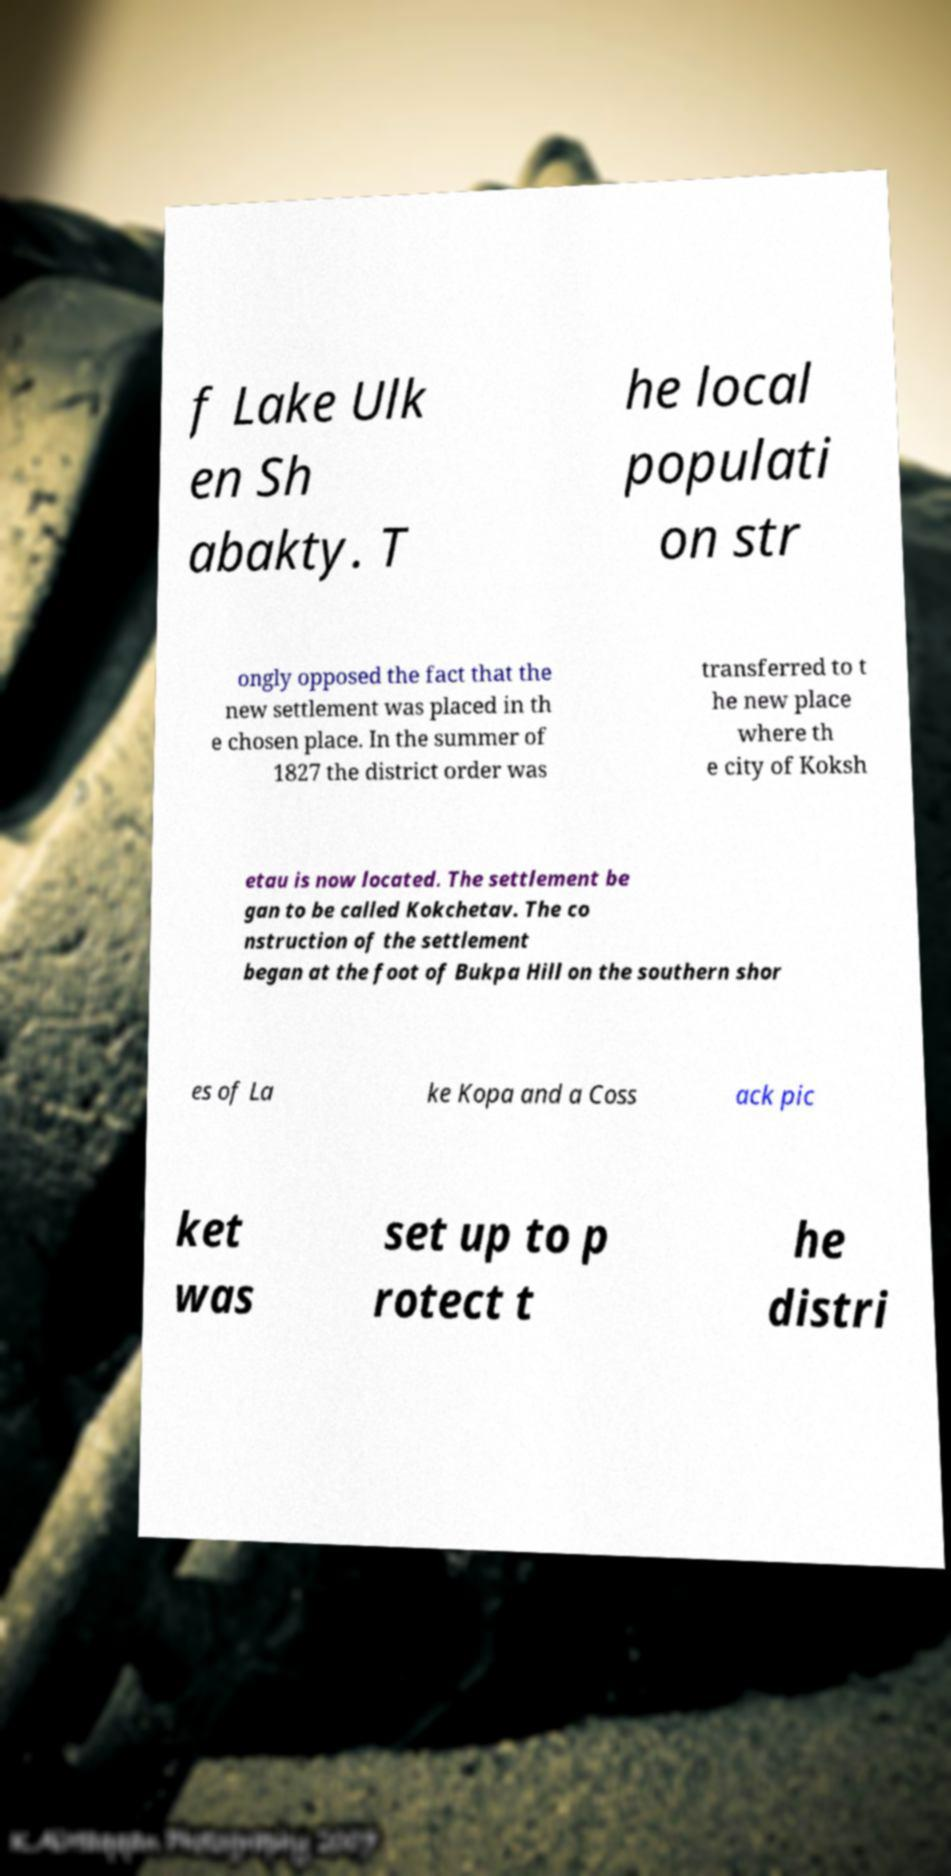Can you accurately transcribe the text from the provided image for me? f Lake Ulk en Sh abakty. T he local populati on str ongly opposed the fact that the new settlement was placed in th e chosen place. In the summer of 1827 the district order was transferred to t he new place where th e city of Koksh etau is now located. The settlement be gan to be called Kokchetav. The co nstruction of the settlement began at the foot of Bukpa Hill on the southern shor es of La ke Kopa and a Coss ack pic ket was set up to p rotect t he distri 